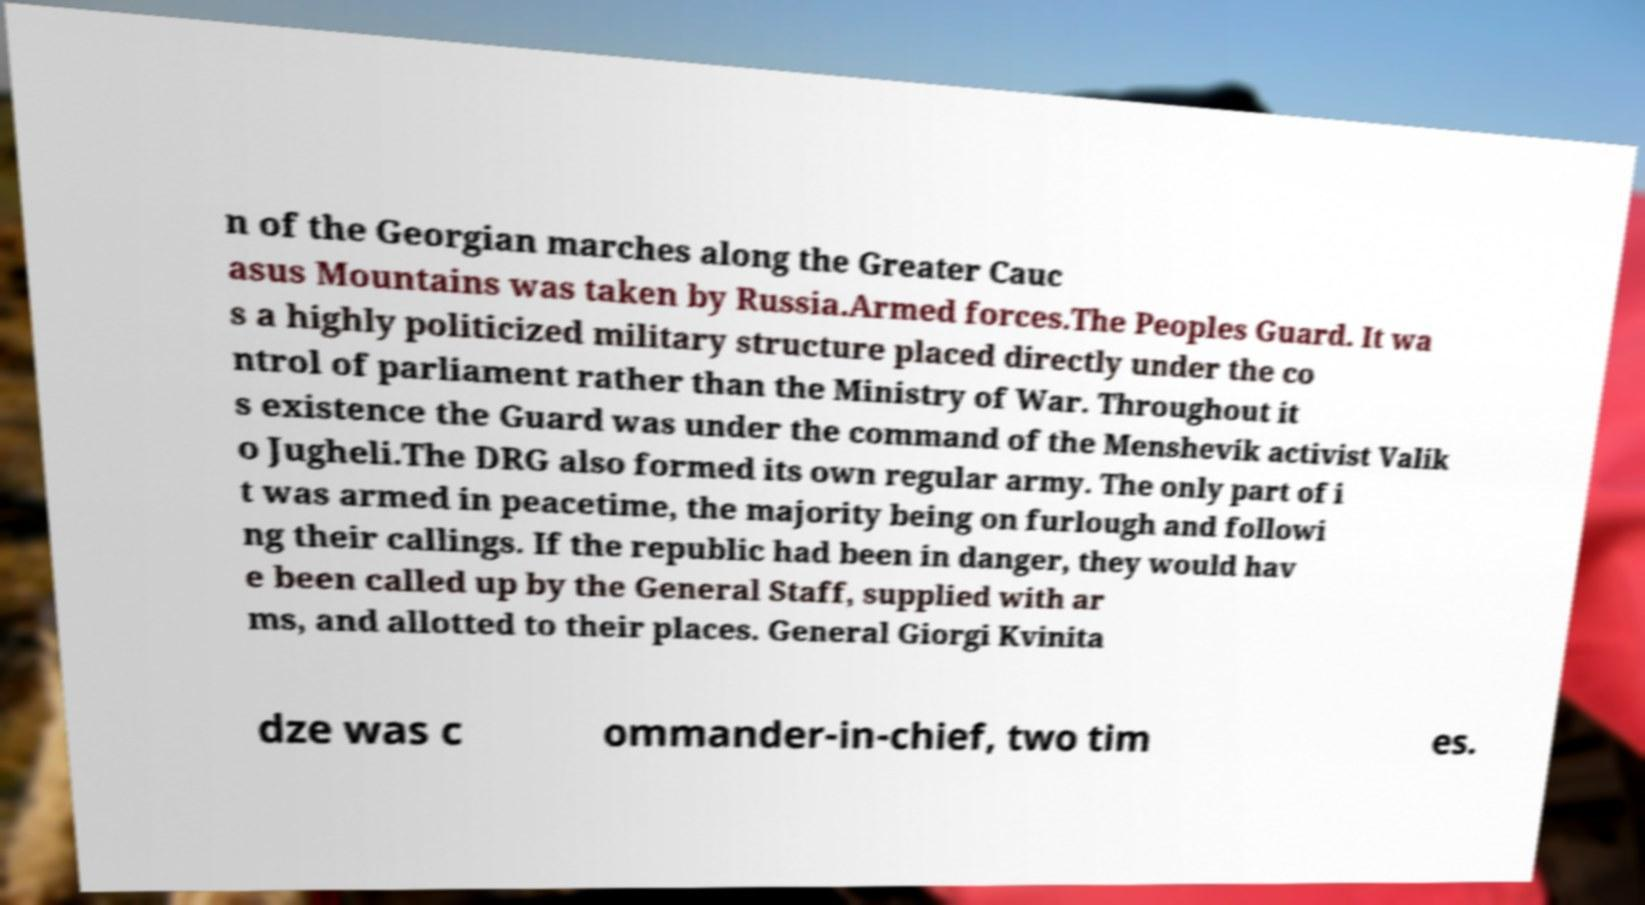Could you assist in decoding the text presented in this image and type it out clearly? n of the Georgian marches along the Greater Cauc asus Mountains was taken by Russia.Armed forces.The Peoples Guard. It wa s a highly politicized military structure placed directly under the co ntrol of parliament rather than the Ministry of War. Throughout it s existence the Guard was under the command of the Menshevik activist Valik o Jugheli.The DRG also formed its own regular army. The only part of i t was armed in peacetime, the majority being on furlough and followi ng their callings. If the republic had been in danger, they would hav e been called up by the General Staff, supplied with ar ms, and allotted to their places. General Giorgi Kvinita dze was c ommander-in-chief, two tim es. 